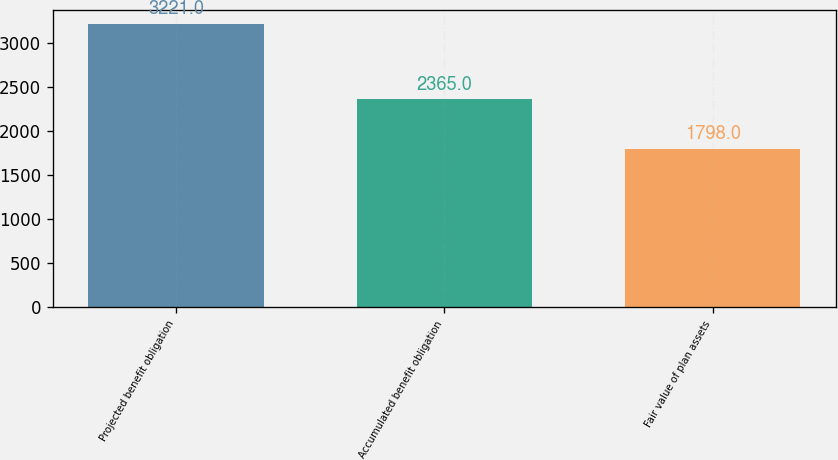Convert chart. <chart><loc_0><loc_0><loc_500><loc_500><bar_chart><fcel>Projected benefit obligation<fcel>Accumulated benefit obligation<fcel>Fair value of plan assets<nl><fcel>3221<fcel>2365<fcel>1798<nl></chart> 